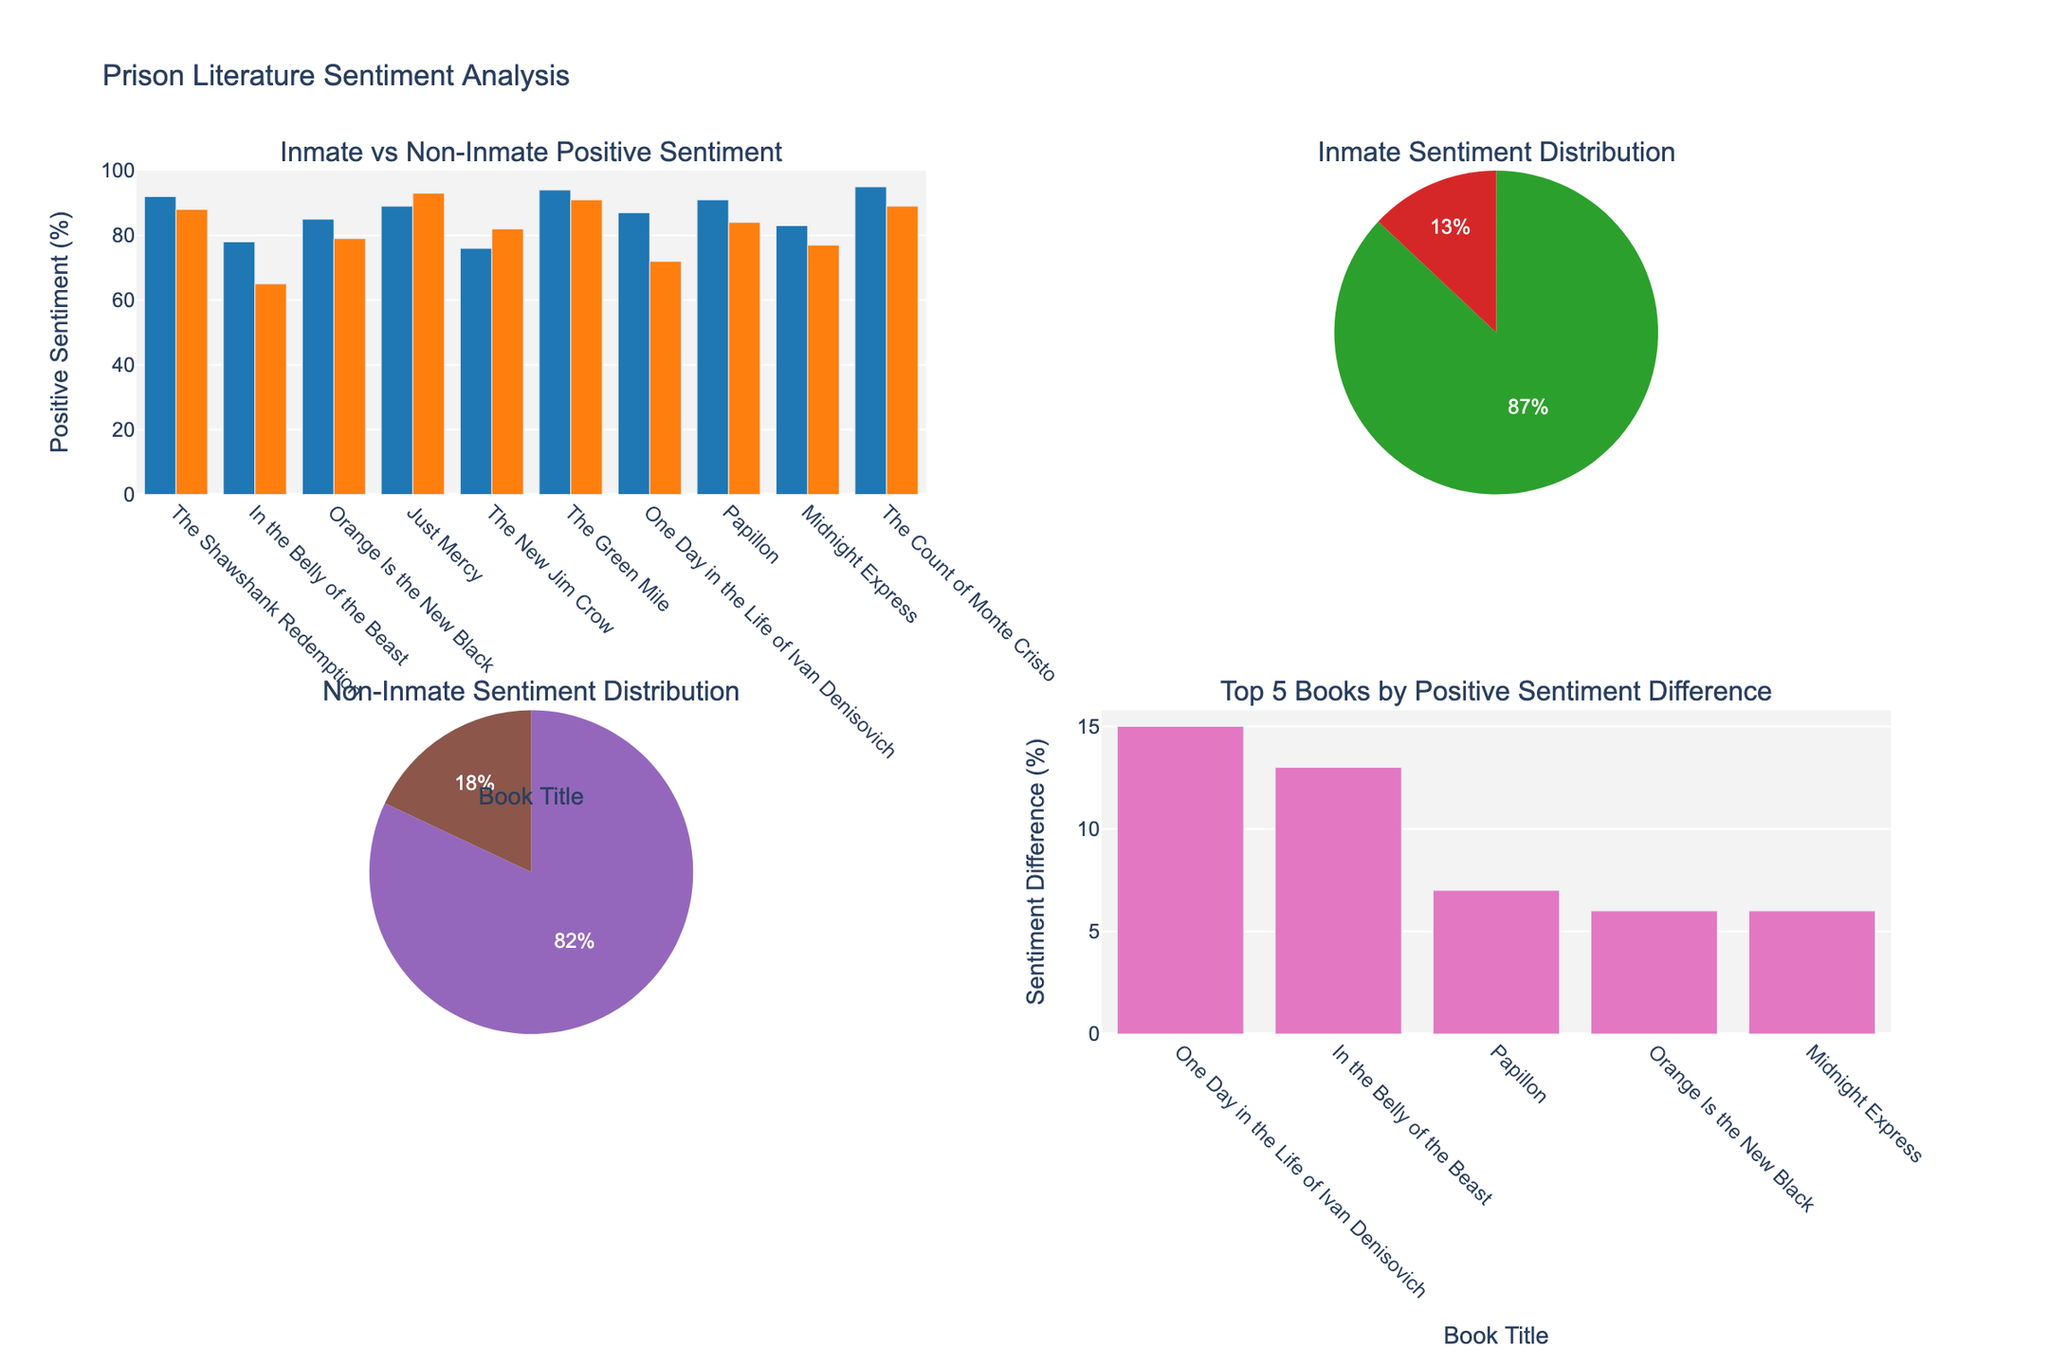What book has the highest positive sentiment among non-inmate readers? Look at the bar in the "Inmate vs Non-Inmate Positive Sentiment" subplot. For non-inmate readers (orange bars), identify the book with the tallest bar.
Answer: Just Mercy Which book shows the largest positive sentiment difference between inmate and non-inmate readers? Refer to the "Top 5 Books by Positive Sentiment Difference" bar chart. The book with the highest bar has the largest positive sentiment difference.
Answer: One Day in the Life of Ivan Denisovich In the "Inmate Sentiment Distribution" pie chart, what is the percentage of positive sentiment? Examine the pie chart labeled "Inmate Sentiment Distribution" and locate the percentage for the 'Positive' slice.
Answer: 87% How many books have higher positive sentiment from inmates compared to non-inmates? In the "Inmate vs Non-Inmate Positive Sentiment" subplot, compare the heights of blue and orange bars for each book. Count books where the blue bar is taller.
Answer: 7 What is the average positive sentiment percentage for non-inmates across all books? On the "Non-Inmate Sentiment Distribution" pie chart, identify and note down the percentage listed for 'Positive'.
Answer: 82% Which book has the smallest sentiment difference between inmates and non-inmates? Refer to the "Top 5 Books by Positive Sentiment Difference" chart and identify the book with the shortest bar.
Answer: Just Mercy What is the title of the subplot showing the individual book comparisons of both inmate and non-inmate positive sentiment? Look at the subplot titles in the figure; find and match the one related to individual book comparisons.
Answer: Inmate vs Non-Inmate Positive Sentiment Which pie chart shows the overall sentiment of non-inmate readers? Identify the pie chart that includes the labels "Positive" and "Negative" under the non-inmate category in the subplot title.
Answer: Bottom-left pie chart Among the books listed, which one has the highest positive sentiment from inmates? In the "Inmate vs Non-Inmate Positive Sentiment" subplot, the book with the highest blue bar represents inmate positive sentiment.
Answer: The Count of Monte Cristo 